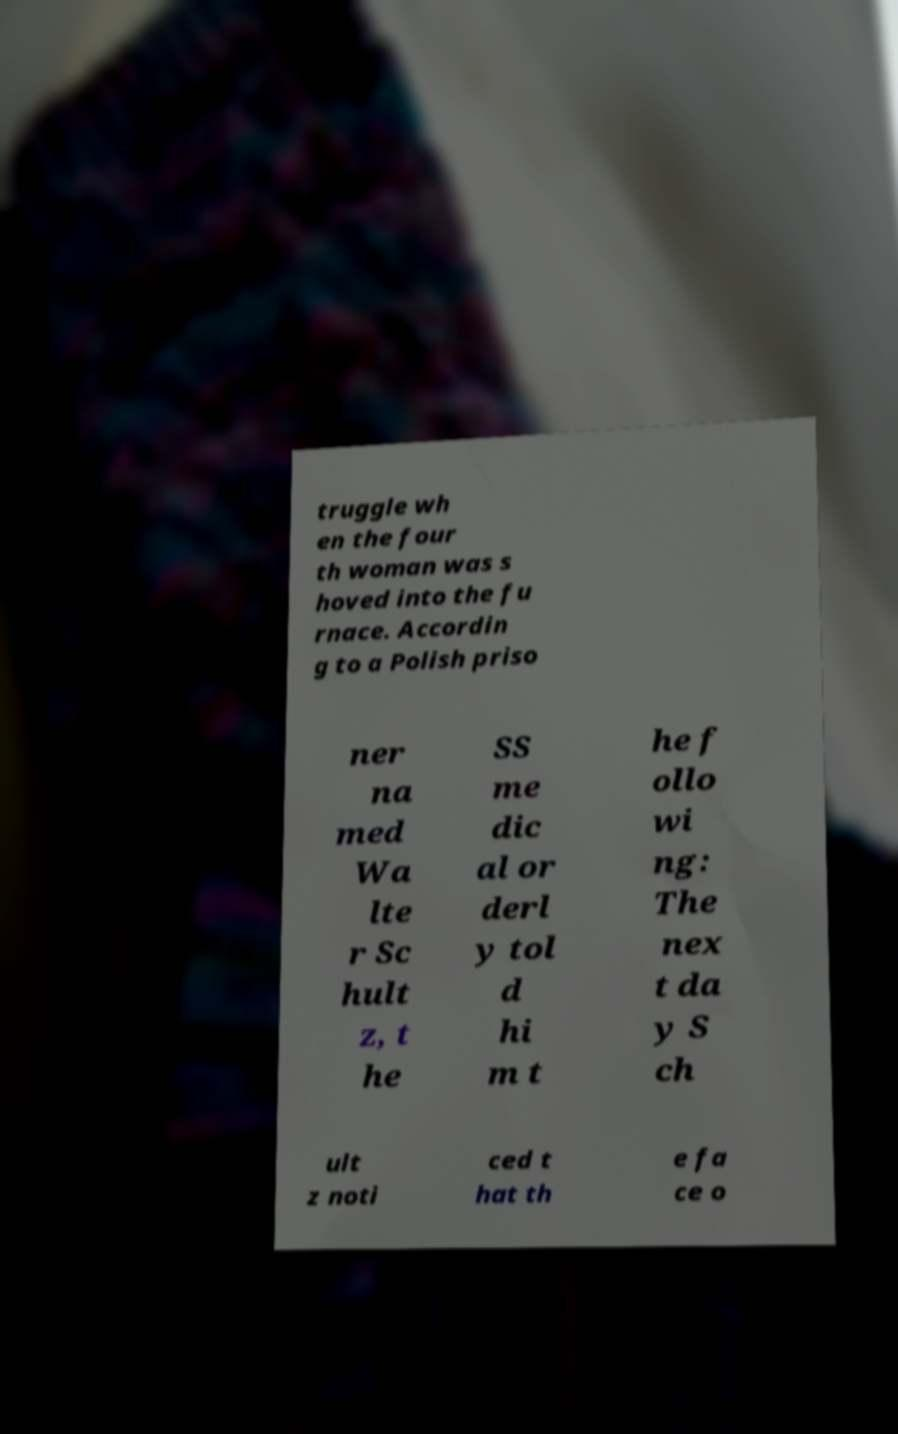Could you assist in decoding the text presented in this image and type it out clearly? truggle wh en the four th woman was s hoved into the fu rnace. Accordin g to a Polish priso ner na med Wa lte r Sc hult z, t he SS me dic al or derl y tol d hi m t he f ollo wi ng: The nex t da y S ch ult z noti ced t hat th e fa ce o 